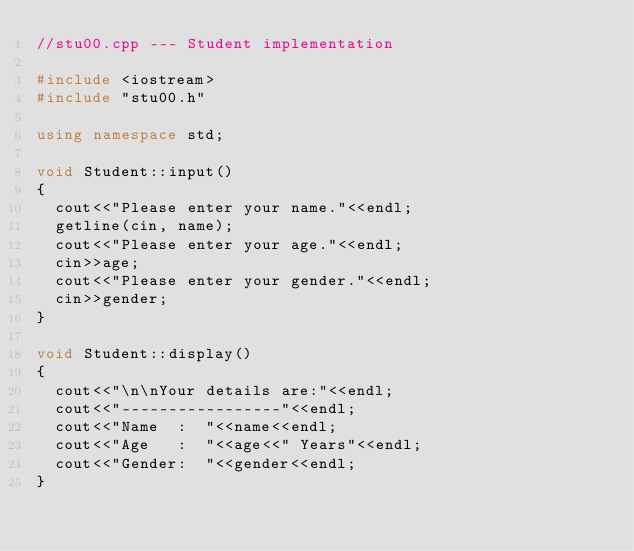Convert code to text. <code><loc_0><loc_0><loc_500><loc_500><_C++_>//stu00.cpp --- Student implementation

#include <iostream>
#include "stu00.h"

using namespace std;

void Student::input()
{
	cout<<"Please enter your name."<<endl;
	getline(cin, name);
	cout<<"Please enter your age."<<endl;
	cin>>age;
	cout<<"Please enter your gender."<<endl;
	cin>>gender;
}

void Student::display()
{
	cout<<"\n\nYour details are:"<<endl;
	cout<<"-----------------"<<endl;
	cout<<"Name  :  "<<name<<endl;
	cout<<"Age   :  "<<age<<" Years"<<endl;
	cout<<"Gender:  "<<gender<<endl;
}</code> 